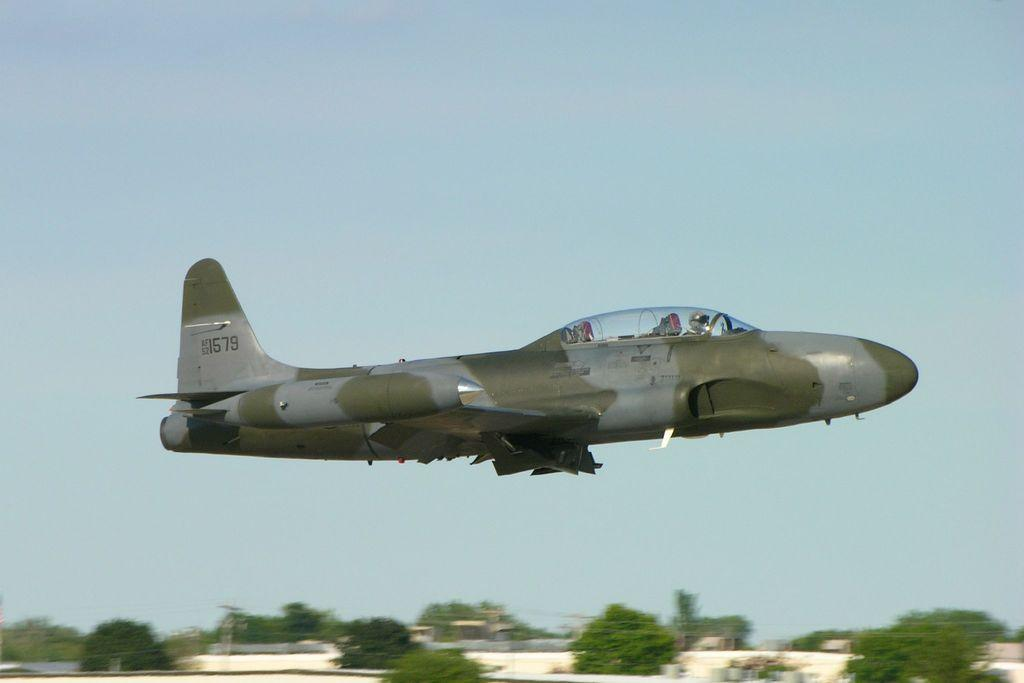What is the person in the image wearing on their head? The person in the image is wearing a helmet. Where is the person sitting in the image? The person is sitting in an airplane. What is the airplane doing in the image? The airplane is flying in the sky. What can be seen in the background of the image? There is a group of trees in the background of the image. What type of health benefits does the throne in the image provide? There is no throne present in the image; it features a person wearing a helmet and sitting in an airplane flying in the sky. 